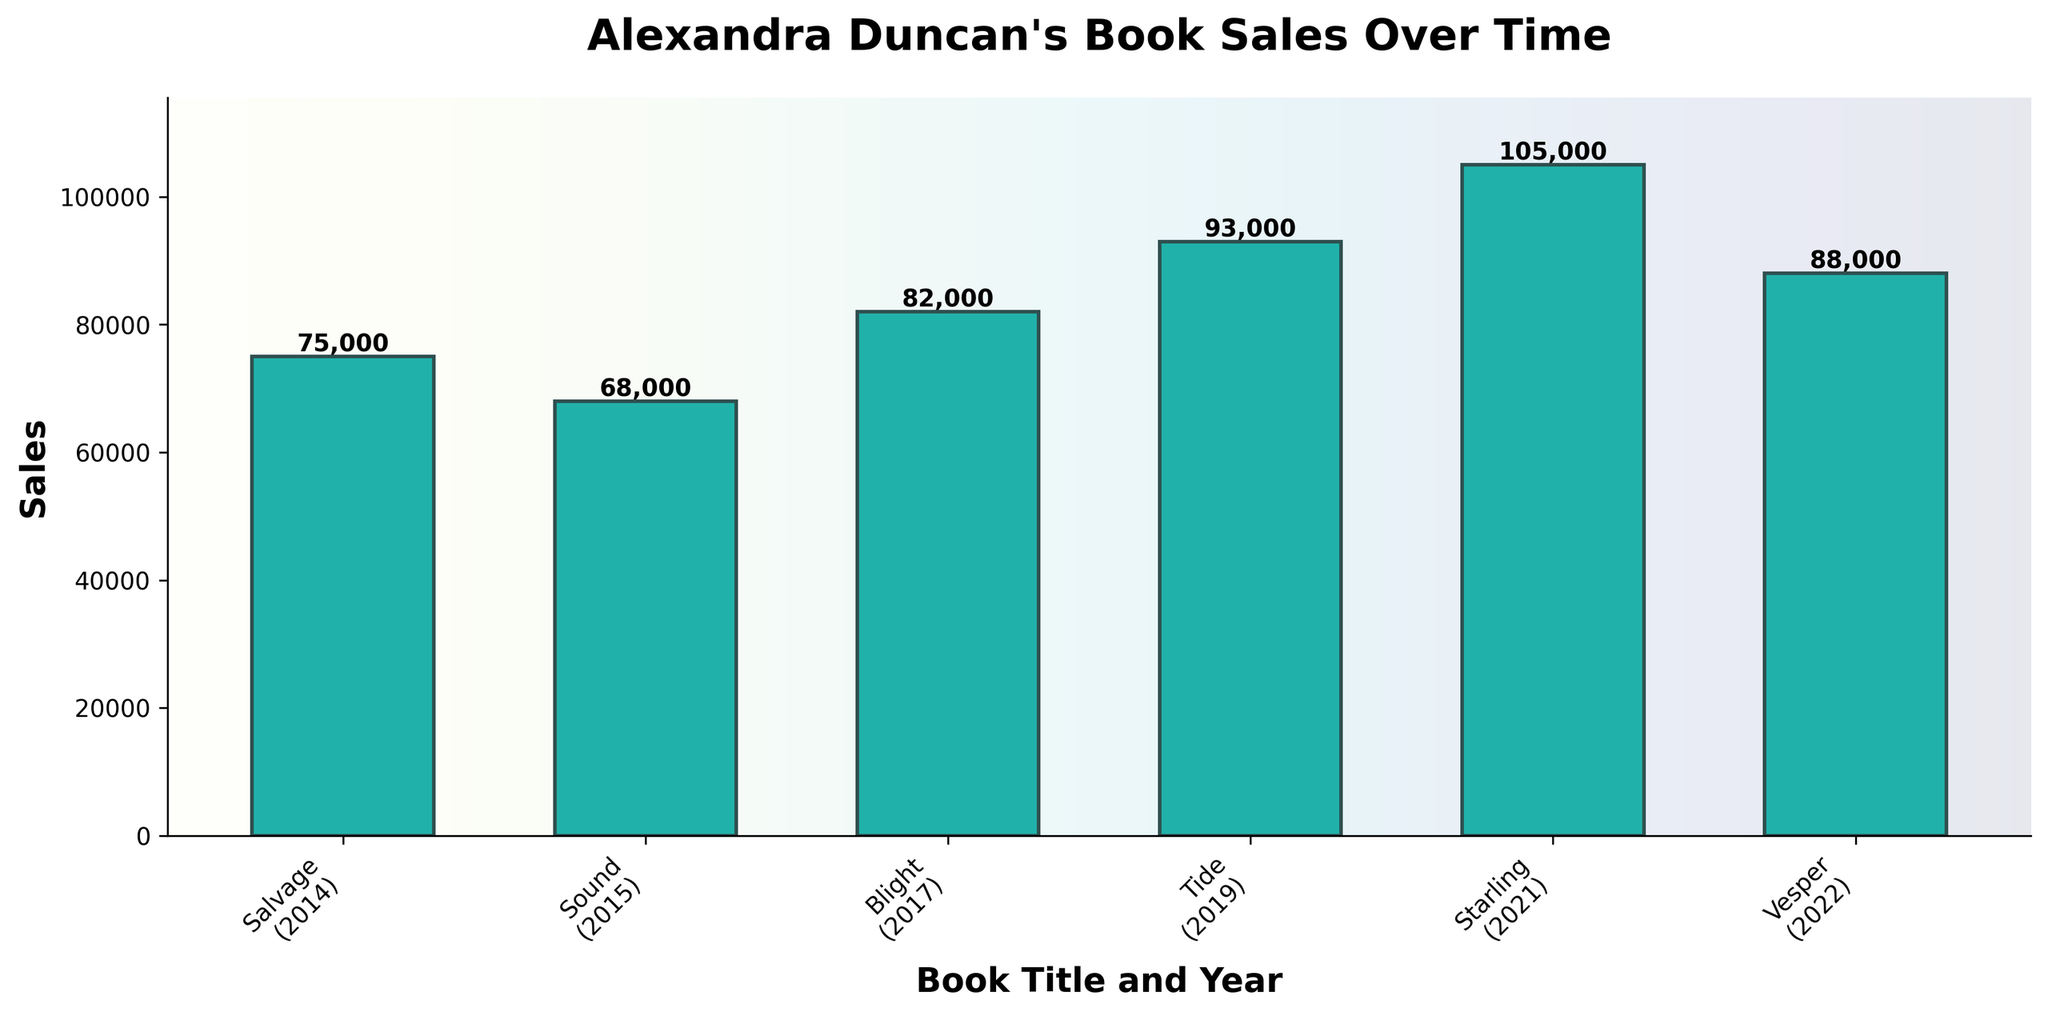What is the total sales of all the books combined? First, sum up the sales of each book: Salvage (75,000) + Sound (68,000) + Blight (82,000) + Tide (93,000) + Starling (105,000) + Vesper (88,000). The total is 75,000 + 68,000 + 82,000 + 93,000 + 105,000 + 88,000 = 511,000.
Answer: 511,000 Which book has the highest sales? Identify the book with the tallest bar. The highest bar represents Starling with 105,000 sales.
Answer: Starling How many books have sales greater than 80,000? Count the number of bars that exceed the 80,000 sales value. The books are Blight (82,000), Tide (93,000), Starling (105,000), and Vesper (88,000), totaling four books.
Answer: 4 How do the sales of Tide compare to Salvage? Compare the heights of the bars for Tide and Salvage. Tide has sales of 93,000 while Salvage has sales of 75,000. Tide has higher sales.
Answer: Tide has higher sales What is the difference in sales between Starling and Sound? Subtract the sales of Sound from the sales of Starling: 105,000 (Starling) - 68,000 (Sound) = 37,000.
Answer: 37,000 Which book was published in 2019 and what are its sales? Check the x-axis labels for the year 2019, which corresponds to Tide. Tide has sales of 93,000.
Answer: Tide, 93,000 What is the average sales amount for all the books? Sum up the total sales: 75,000 + 68,000 + 82,000 + 93,000 + 105,000 + 88,000 = 511,000. There are 6 books, so the average is 511,000 / 6 = 85,167.
Answer: 85,167 What are the second highest sales and which book achieved it? Identify the highest sales first, which is Starling at 105,000. The second-highest is Tide with 93,000.
Answer: 93,000, Tide What's the range of the sales figures for all the books? Determine the difference between the highest and lowest sales: 105,000 (highest for Starling) - 68,000 (lowest for Sound) = 37,000.
Answer: 37,000 Which book's sales are closest to the average sales amount? The average sales amount is 85,167. Compare each book's sales to this number: Salvage (75,000), Sound (68,000), Blight (82,000), Tide (93,000), Starling (105,000), Vesper (88,000). The closest is Blight with 82,000 sales.
Answer: Blight 